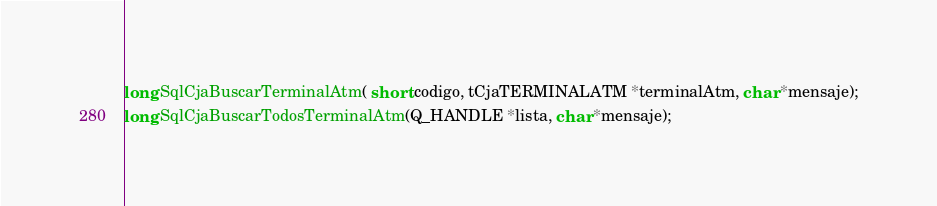<code> <loc_0><loc_0><loc_500><loc_500><_C_>long SqlCjaBuscarTerminalAtm( short codigo, tCjaTERMINALATM *terminalAtm, char *mensaje);
long SqlCjaBuscarTodosTerminalAtm(Q_HANDLE *lista, char *mensaje);
</code> 